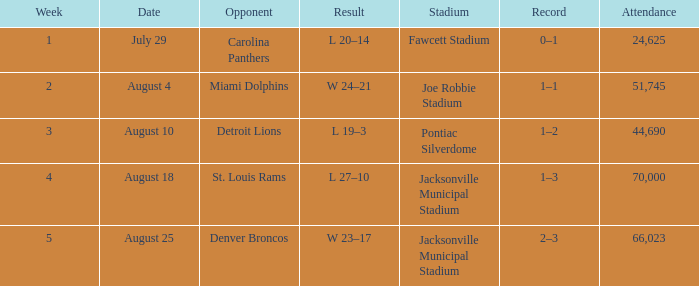What is the Record in Week 2? 1–1. 